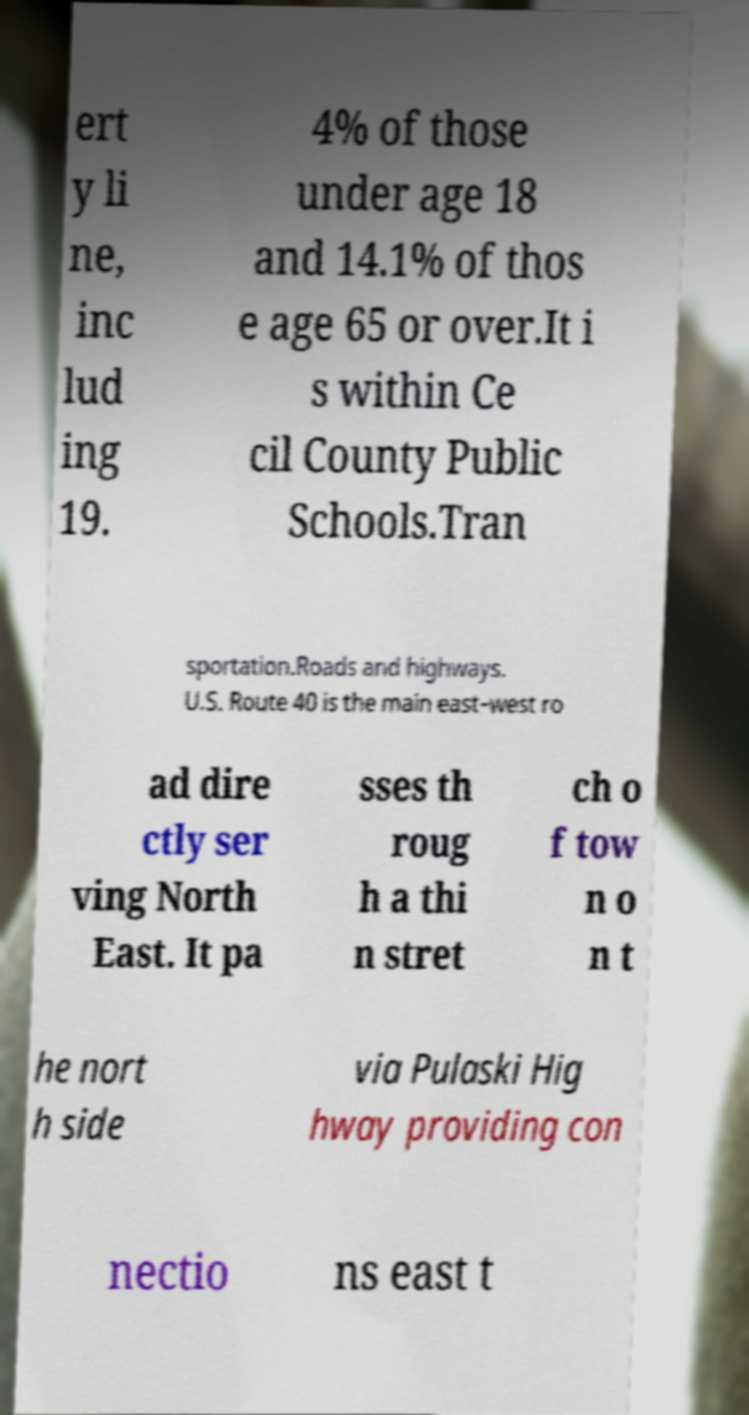Could you assist in decoding the text presented in this image and type it out clearly? ert y li ne, inc lud ing 19. 4% of those under age 18 and 14.1% of thos e age 65 or over.It i s within Ce cil County Public Schools.Tran sportation.Roads and highways. U.S. Route 40 is the main east–west ro ad dire ctly ser ving North East. It pa sses th roug h a thi n stret ch o f tow n o n t he nort h side via Pulaski Hig hway providing con nectio ns east t 